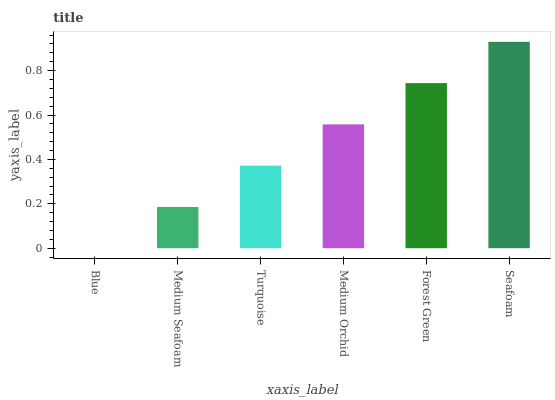Is Blue the minimum?
Answer yes or no. Yes. Is Seafoam the maximum?
Answer yes or no. Yes. Is Medium Seafoam the minimum?
Answer yes or no. No. Is Medium Seafoam the maximum?
Answer yes or no. No. Is Medium Seafoam greater than Blue?
Answer yes or no. Yes. Is Blue less than Medium Seafoam?
Answer yes or no. Yes. Is Blue greater than Medium Seafoam?
Answer yes or no. No. Is Medium Seafoam less than Blue?
Answer yes or no. No. Is Medium Orchid the high median?
Answer yes or no. Yes. Is Turquoise the low median?
Answer yes or no. Yes. Is Seafoam the high median?
Answer yes or no. No. Is Blue the low median?
Answer yes or no. No. 